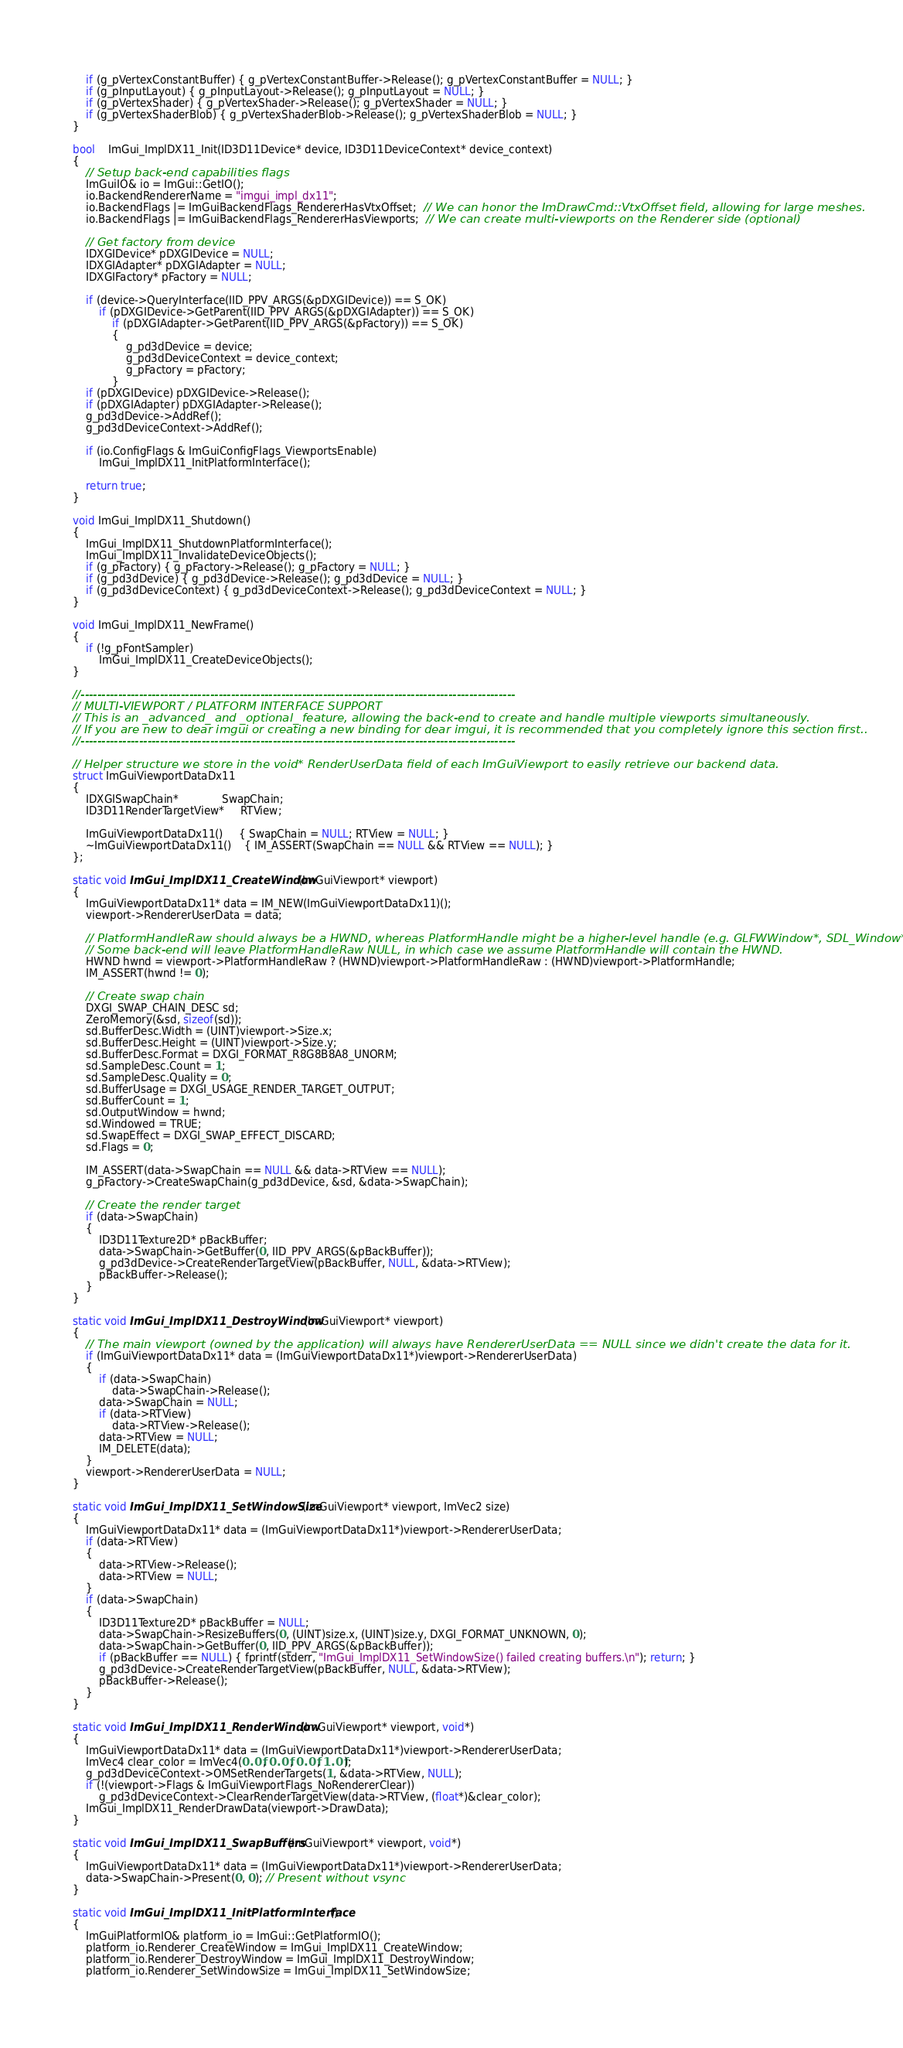Convert code to text. <code><loc_0><loc_0><loc_500><loc_500><_C++_>    if (g_pVertexConstantBuffer) { g_pVertexConstantBuffer->Release(); g_pVertexConstantBuffer = NULL; }
    if (g_pInputLayout) { g_pInputLayout->Release(); g_pInputLayout = NULL; }
    if (g_pVertexShader) { g_pVertexShader->Release(); g_pVertexShader = NULL; }
    if (g_pVertexShaderBlob) { g_pVertexShaderBlob->Release(); g_pVertexShaderBlob = NULL; }
}

bool    ImGui_ImplDX11_Init(ID3D11Device* device, ID3D11DeviceContext* device_context)
{
    // Setup back-end capabilities flags
    ImGuiIO& io = ImGui::GetIO();
    io.BackendRendererName = "imgui_impl_dx11";
    io.BackendFlags |= ImGuiBackendFlags_RendererHasVtxOffset;  // We can honor the ImDrawCmd::VtxOffset field, allowing for large meshes.
    io.BackendFlags |= ImGuiBackendFlags_RendererHasViewports;  // We can create multi-viewports on the Renderer side (optional)

    // Get factory from device
    IDXGIDevice* pDXGIDevice = NULL;
    IDXGIAdapter* pDXGIAdapter = NULL;
    IDXGIFactory* pFactory = NULL;

    if (device->QueryInterface(IID_PPV_ARGS(&pDXGIDevice)) == S_OK)
        if (pDXGIDevice->GetParent(IID_PPV_ARGS(&pDXGIAdapter)) == S_OK)
            if (pDXGIAdapter->GetParent(IID_PPV_ARGS(&pFactory)) == S_OK)
            {
                g_pd3dDevice = device;
                g_pd3dDeviceContext = device_context;
                g_pFactory = pFactory;
            }
    if (pDXGIDevice) pDXGIDevice->Release();
    if (pDXGIAdapter) pDXGIAdapter->Release();
    g_pd3dDevice->AddRef();
    g_pd3dDeviceContext->AddRef();

    if (io.ConfigFlags & ImGuiConfigFlags_ViewportsEnable)
        ImGui_ImplDX11_InitPlatformInterface();

    return true;
}

void ImGui_ImplDX11_Shutdown()
{
    ImGui_ImplDX11_ShutdownPlatformInterface();
    ImGui_ImplDX11_InvalidateDeviceObjects();
    if (g_pFactory) { g_pFactory->Release(); g_pFactory = NULL; }
    if (g_pd3dDevice) { g_pd3dDevice->Release(); g_pd3dDevice = NULL; }
    if (g_pd3dDeviceContext) { g_pd3dDeviceContext->Release(); g_pd3dDeviceContext = NULL; }
}

void ImGui_ImplDX11_NewFrame()
{
    if (!g_pFontSampler)
        ImGui_ImplDX11_CreateDeviceObjects();
}

//--------------------------------------------------------------------------------------------------------
// MULTI-VIEWPORT / PLATFORM INTERFACE SUPPORT
// This is an _advanced_ and _optional_ feature, allowing the back-end to create and handle multiple viewports simultaneously.
// If you are new to dear imgui or creating a new binding for dear imgui, it is recommended that you completely ignore this section first..
//--------------------------------------------------------------------------------------------------------

// Helper structure we store in the void* RenderUserData field of each ImGuiViewport to easily retrieve our backend data.
struct ImGuiViewportDataDx11
{
    IDXGISwapChain*             SwapChain;
    ID3D11RenderTargetView*     RTView;

    ImGuiViewportDataDx11()     { SwapChain = NULL; RTView = NULL; }
    ~ImGuiViewportDataDx11()    { IM_ASSERT(SwapChain == NULL && RTView == NULL); }
};

static void ImGui_ImplDX11_CreateWindow(ImGuiViewport* viewport)
{
    ImGuiViewportDataDx11* data = IM_NEW(ImGuiViewportDataDx11)();
    viewport->RendererUserData = data;

    // PlatformHandleRaw should always be a HWND, whereas PlatformHandle might be a higher-level handle (e.g. GLFWWindow*, SDL_Window*).
    // Some back-end will leave PlatformHandleRaw NULL, in which case we assume PlatformHandle will contain the HWND.
    HWND hwnd = viewport->PlatformHandleRaw ? (HWND)viewport->PlatformHandleRaw : (HWND)viewport->PlatformHandle;
    IM_ASSERT(hwnd != 0);

    // Create swap chain
    DXGI_SWAP_CHAIN_DESC sd;
    ZeroMemory(&sd, sizeof(sd));
    sd.BufferDesc.Width = (UINT)viewport->Size.x;
    sd.BufferDesc.Height = (UINT)viewport->Size.y;
    sd.BufferDesc.Format = DXGI_FORMAT_R8G8B8A8_UNORM;
    sd.SampleDesc.Count = 1;
    sd.SampleDesc.Quality = 0;
    sd.BufferUsage = DXGI_USAGE_RENDER_TARGET_OUTPUT;
    sd.BufferCount = 1;
    sd.OutputWindow = hwnd;
    sd.Windowed = TRUE;
    sd.SwapEffect = DXGI_SWAP_EFFECT_DISCARD;
    sd.Flags = 0;

    IM_ASSERT(data->SwapChain == NULL && data->RTView == NULL);
    g_pFactory->CreateSwapChain(g_pd3dDevice, &sd, &data->SwapChain);

    // Create the render target
    if (data->SwapChain)
    {
        ID3D11Texture2D* pBackBuffer;
        data->SwapChain->GetBuffer(0, IID_PPV_ARGS(&pBackBuffer));
        g_pd3dDevice->CreateRenderTargetView(pBackBuffer, NULL, &data->RTView);
        pBackBuffer->Release();
    }
}

static void ImGui_ImplDX11_DestroyWindow(ImGuiViewport* viewport)
{
    // The main viewport (owned by the application) will always have RendererUserData == NULL since we didn't create the data for it.
    if (ImGuiViewportDataDx11* data = (ImGuiViewportDataDx11*)viewport->RendererUserData)
    {
        if (data->SwapChain)
            data->SwapChain->Release();
        data->SwapChain = NULL;
        if (data->RTView)
            data->RTView->Release();
        data->RTView = NULL;
        IM_DELETE(data);
    }
    viewport->RendererUserData = NULL;
}

static void ImGui_ImplDX11_SetWindowSize(ImGuiViewport* viewport, ImVec2 size)
{
    ImGuiViewportDataDx11* data = (ImGuiViewportDataDx11*)viewport->RendererUserData;
    if (data->RTView)
    {
        data->RTView->Release();
        data->RTView = NULL;
    }
    if (data->SwapChain)
    {
        ID3D11Texture2D* pBackBuffer = NULL;
        data->SwapChain->ResizeBuffers(0, (UINT)size.x, (UINT)size.y, DXGI_FORMAT_UNKNOWN, 0);
        data->SwapChain->GetBuffer(0, IID_PPV_ARGS(&pBackBuffer));
        if (pBackBuffer == NULL) { fprintf(stderr, "ImGui_ImplDX11_SetWindowSize() failed creating buffers.\n"); return; }
        g_pd3dDevice->CreateRenderTargetView(pBackBuffer, NULL, &data->RTView);
        pBackBuffer->Release();
    }
}

static void ImGui_ImplDX11_RenderWindow(ImGuiViewport* viewport, void*)
{
    ImGuiViewportDataDx11* data = (ImGuiViewportDataDx11*)viewport->RendererUserData;
    ImVec4 clear_color = ImVec4(0.0f, 0.0f, 0.0f, 1.0f);
    g_pd3dDeviceContext->OMSetRenderTargets(1, &data->RTView, NULL);
    if (!(viewport->Flags & ImGuiViewportFlags_NoRendererClear))
        g_pd3dDeviceContext->ClearRenderTargetView(data->RTView, (float*)&clear_color);
    ImGui_ImplDX11_RenderDrawData(viewport->DrawData);
}

static void ImGui_ImplDX11_SwapBuffers(ImGuiViewport* viewport, void*)
{
    ImGuiViewportDataDx11* data = (ImGuiViewportDataDx11*)viewport->RendererUserData;
    data->SwapChain->Present(0, 0); // Present without vsync
}

static void ImGui_ImplDX11_InitPlatformInterface()
{
    ImGuiPlatformIO& platform_io = ImGui::GetPlatformIO();
    platform_io.Renderer_CreateWindow = ImGui_ImplDX11_CreateWindow;
    platform_io.Renderer_DestroyWindow = ImGui_ImplDX11_DestroyWindow;
    platform_io.Renderer_SetWindowSize = ImGui_ImplDX11_SetWindowSize;</code> 